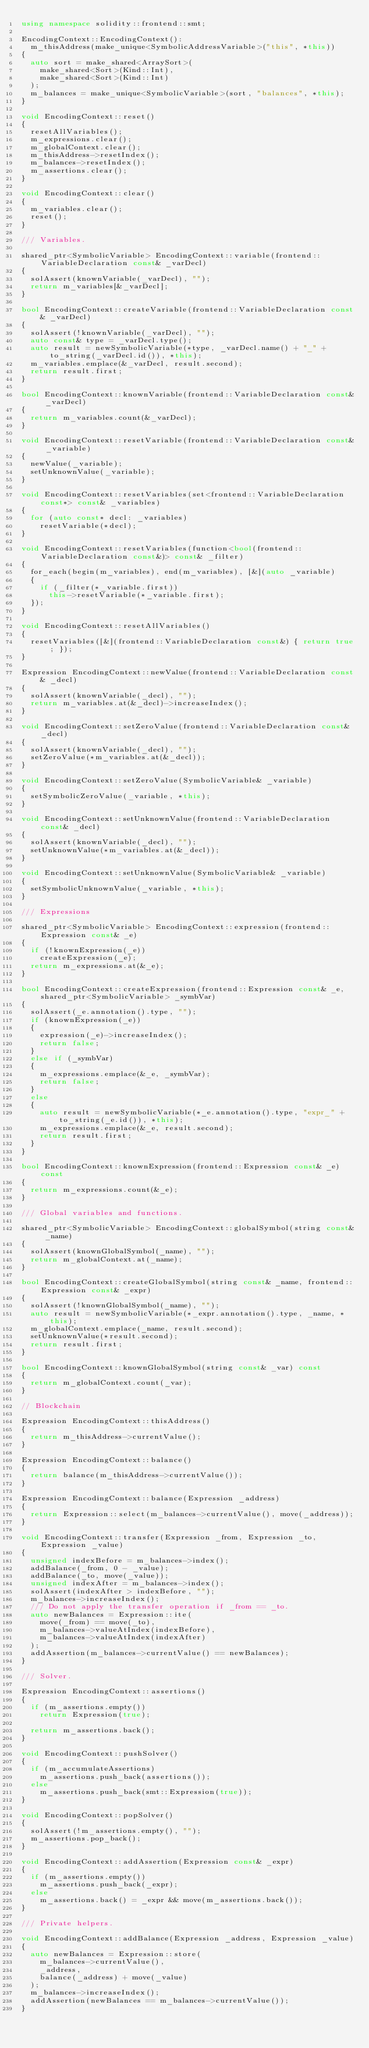Convert code to text. <code><loc_0><loc_0><loc_500><loc_500><_C++_>using namespace solidity::frontend::smt;

EncodingContext::EncodingContext():
	m_thisAddress(make_unique<SymbolicAddressVariable>("this", *this))
{
	auto sort = make_shared<ArraySort>(
		make_shared<Sort>(Kind::Int),
		make_shared<Sort>(Kind::Int)
	);
	m_balances = make_unique<SymbolicVariable>(sort, "balances", *this);
}

void EncodingContext::reset()
{
	resetAllVariables();
	m_expressions.clear();
	m_globalContext.clear();
	m_thisAddress->resetIndex();
	m_balances->resetIndex();
	m_assertions.clear();
}

void EncodingContext::clear()
{
	m_variables.clear();
	reset();
}

/// Variables.

shared_ptr<SymbolicVariable> EncodingContext::variable(frontend::VariableDeclaration const& _varDecl)
{
	solAssert(knownVariable(_varDecl), "");
	return m_variables[&_varDecl];
}

bool EncodingContext::createVariable(frontend::VariableDeclaration const& _varDecl)
{
	solAssert(!knownVariable(_varDecl), "");
	auto const& type = _varDecl.type();
	auto result = newSymbolicVariable(*type, _varDecl.name() + "_" + to_string(_varDecl.id()), *this);
	m_variables.emplace(&_varDecl, result.second);
	return result.first;
}

bool EncodingContext::knownVariable(frontend::VariableDeclaration const& _varDecl)
{
	return m_variables.count(&_varDecl);
}

void EncodingContext::resetVariable(frontend::VariableDeclaration const& _variable)
{
	newValue(_variable);
	setUnknownValue(_variable);
}

void EncodingContext::resetVariables(set<frontend::VariableDeclaration const*> const& _variables)
{
	for (auto const* decl: _variables)
		resetVariable(*decl);
}

void EncodingContext::resetVariables(function<bool(frontend::VariableDeclaration const&)> const& _filter)
{
	for_each(begin(m_variables), end(m_variables), [&](auto _variable)
	{
		if (_filter(*_variable.first))
			this->resetVariable(*_variable.first);
	});
}

void EncodingContext::resetAllVariables()
{
	resetVariables([&](frontend::VariableDeclaration const&) { return true; });
}

Expression EncodingContext::newValue(frontend::VariableDeclaration const& _decl)
{
	solAssert(knownVariable(_decl), "");
	return m_variables.at(&_decl)->increaseIndex();
}

void EncodingContext::setZeroValue(frontend::VariableDeclaration const& _decl)
{
	solAssert(knownVariable(_decl), "");
	setZeroValue(*m_variables.at(&_decl));
}

void EncodingContext::setZeroValue(SymbolicVariable& _variable)
{
	setSymbolicZeroValue(_variable, *this);
}

void EncodingContext::setUnknownValue(frontend::VariableDeclaration const& _decl)
{
	solAssert(knownVariable(_decl), "");
	setUnknownValue(*m_variables.at(&_decl));
}

void EncodingContext::setUnknownValue(SymbolicVariable& _variable)
{
	setSymbolicUnknownValue(_variable, *this);
}

/// Expressions

shared_ptr<SymbolicVariable> EncodingContext::expression(frontend::Expression const& _e)
{
	if (!knownExpression(_e))
		createExpression(_e);
	return m_expressions.at(&_e);
}

bool EncodingContext::createExpression(frontend::Expression const& _e, shared_ptr<SymbolicVariable> _symbVar)
{
	solAssert(_e.annotation().type, "");
	if (knownExpression(_e))
	{
		expression(_e)->increaseIndex();
		return false;
	}
	else if (_symbVar)
	{
		m_expressions.emplace(&_e, _symbVar);
		return false;
	}
	else
	{
		auto result = newSymbolicVariable(*_e.annotation().type, "expr_" + to_string(_e.id()), *this);
		m_expressions.emplace(&_e, result.second);
		return result.first;
	}
}

bool EncodingContext::knownExpression(frontend::Expression const& _e) const
{
	return m_expressions.count(&_e);
}

/// Global variables and functions.

shared_ptr<SymbolicVariable> EncodingContext::globalSymbol(string const& _name)
{
	solAssert(knownGlobalSymbol(_name), "");
	return m_globalContext.at(_name);
}

bool EncodingContext::createGlobalSymbol(string const& _name, frontend::Expression const& _expr)
{
	solAssert(!knownGlobalSymbol(_name), "");
	auto result = newSymbolicVariable(*_expr.annotation().type, _name, *this);
	m_globalContext.emplace(_name, result.second);
	setUnknownValue(*result.second);
	return result.first;
}

bool EncodingContext::knownGlobalSymbol(string const& _var) const
{
	return m_globalContext.count(_var);
}

// Blockchain

Expression EncodingContext::thisAddress()
{
	return m_thisAddress->currentValue();
}

Expression EncodingContext::balance()
{
	return balance(m_thisAddress->currentValue());
}

Expression EncodingContext::balance(Expression _address)
{
	return Expression::select(m_balances->currentValue(), move(_address));
}

void EncodingContext::transfer(Expression _from, Expression _to, Expression _value)
{
	unsigned indexBefore = m_balances->index();
	addBalance(_from, 0 - _value);
	addBalance(_to, move(_value));
	unsigned indexAfter = m_balances->index();
	solAssert(indexAfter > indexBefore, "");
	m_balances->increaseIndex();
	/// Do not apply the transfer operation if _from == _to.
	auto newBalances = Expression::ite(
		move(_from) == move(_to),
		m_balances->valueAtIndex(indexBefore),
		m_balances->valueAtIndex(indexAfter)
	);
	addAssertion(m_balances->currentValue() == newBalances);
}

/// Solver.

Expression EncodingContext::assertions()
{
	if (m_assertions.empty())
		return Expression(true);

	return m_assertions.back();
}

void EncodingContext::pushSolver()
{
	if (m_accumulateAssertions)
		m_assertions.push_back(assertions());
	else
		m_assertions.push_back(smt::Expression(true));
}

void EncodingContext::popSolver()
{
	solAssert(!m_assertions.empty(), "");
	m_assertions.pop_back();
}

void EncodingContext::addAssertion(Expression const& _expr)
{
	if (m_assertions.empty())
		m_assertions.push_back(_expr);
	else
		m_assertions.back() = _expr && move(m_assertions.back());
}

/// Private helpers.

void EncodingContext::addBalance(Expression _address, Expression _value)
{
	auto newBalances = Expression::store(
		m_balances->currentValue(),
		_address,
		balance(_address) + move(_value)
	);
	m_balances->increaseIndex();
	addAssertion(newBalances == m_balances->currentValue());
}
</code> 